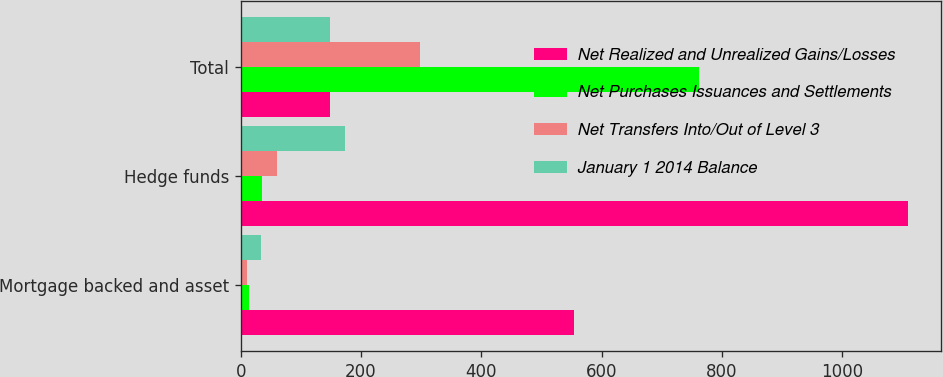Convert chart. <chart><loc_0><loc_0><loc_500><loc_500><stacked_bar_chart><ecel><fcel>Mortgage backed and asset<fcel>Hedge funds<fcel>Total<nl><fcel>Net Realized and Unrealized Gains/Losses<fcel>554<fcel>1109<fcel>149<nl><fcel>Net Purchases Issuances and Settlements<fcel>14<fcel>36<fcel>761<nl><fcel>Net Transfers Into/Out of Level 3<fcel>10<fcel>61<fcel>298<nl><fcel>January 1 2014 Balance<fcel>33<fcel>173<fcel>149<nl></chart> 